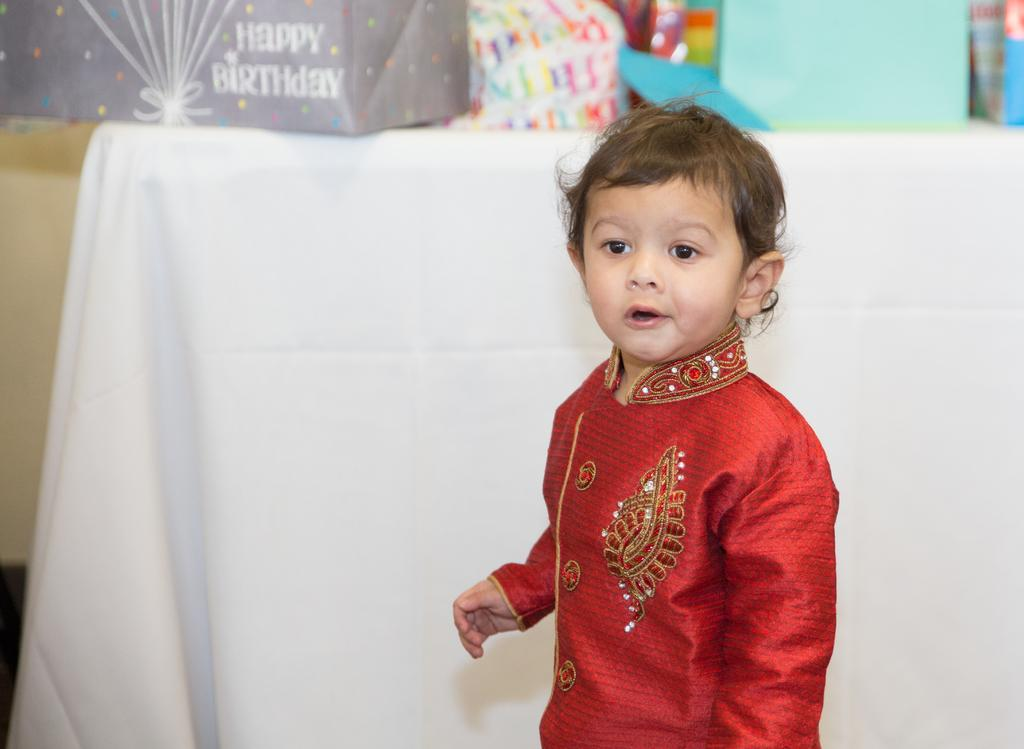Who is the main subject in the image? There is a boy in the image. What is the boy wearing? The boy is wearing a red dress. What can be seen in the background of the image? There is a table in the background of the image. How is the table decorated? The table is covered with a white cloth. What is on top of the table? There are gifts on the table. What type of vest does the boy have on in the image? The boy is not wearing a vest in the image; he is wearing a red dress. 